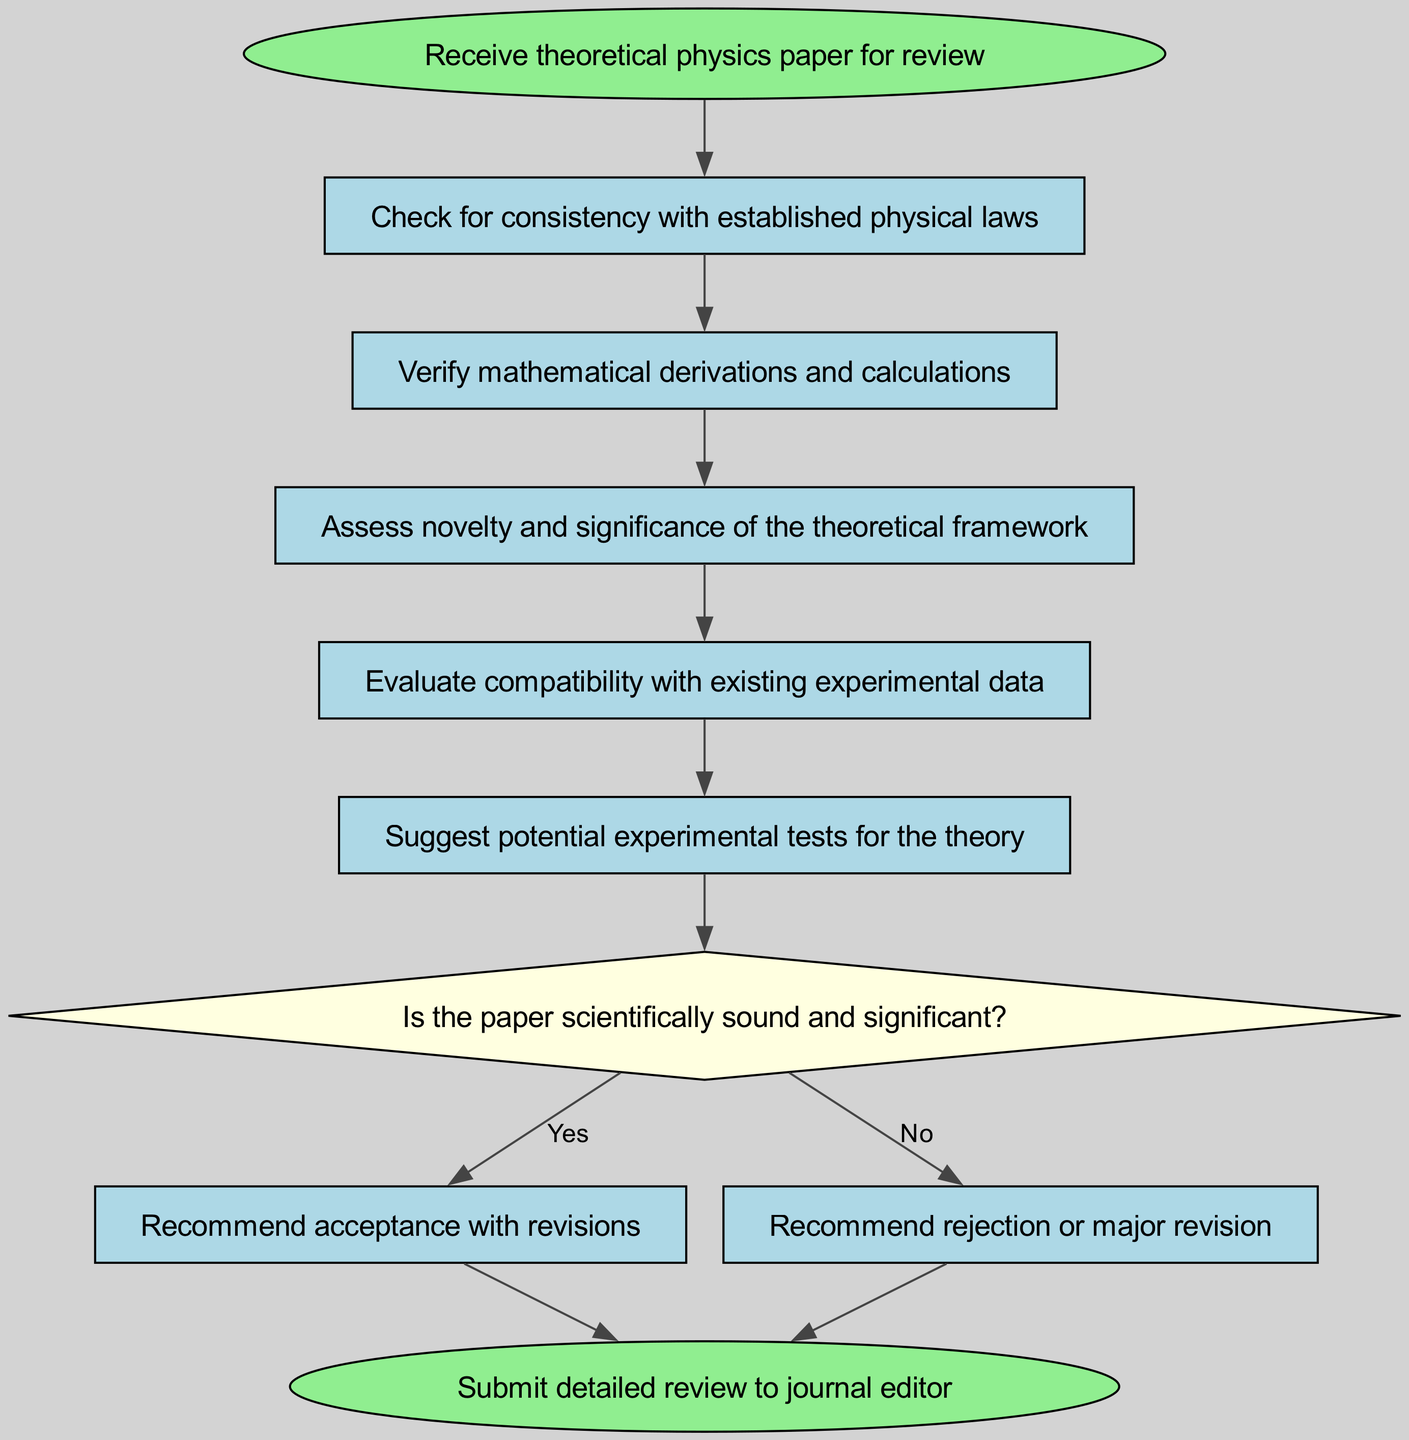What is the first step in the review process? The first step is to "Check for consistency with established physical laws," which follows directly after "Receive theoretical physics paper for review."
Answer: Check for consistency with established physical laws How many steps are there in the review process? Counting all the steps including the start and end points, there are 7 steps: Start, 5 review steps, and End.
Answer: 7 Which step assesses the novelty of the theoretical framework? The step that assesses the novelty and significance of the theoretical framework is labeled "Assess novelty and significance of the theoretical framework," which is the third step in the sequence.
Answer: Assess novelty and significance of the theoretical framework What happens if the paper is deemed scientifically sound? If the paper is scientifically sound and significant, the flowchart indicates that the next action is to "Recommend acceptance with revisions."
Answer: Recommend acceptance with revisions What is suggested after evaluating compatibility with experimental data? After evaluating compatibility with existing experimental data, the reviewer suggests "Suggest potential experimental tests for the theory," which is the fifth step.
Answer: Suggest potential experimental tests for the theory What node represents a decision point in the review process? The decision point in the review process is represented by the node labeled "Is the paper scientifically sound and significant?" which is in the shape of a diamond.
Answer: Is the paper scientifically sound and significant? If the paper is not scientifically sound, what is the outcome? If the paper is not scientifically sound, the recommendation is to "Recommend rejection or major revision," which directly leads to the end of the process.
Answer: Recommend rejection or major revision 